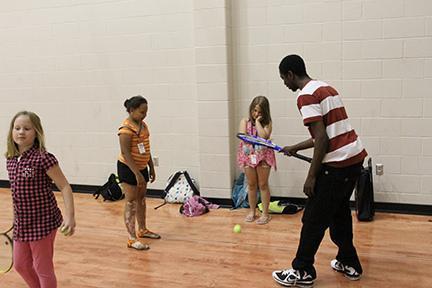How many girls are there?
Give a very brief answer. 3. How many people are there?
Give a very brief answer. 4. How many circle donuts are there?
Give a very brief answer. 0. 